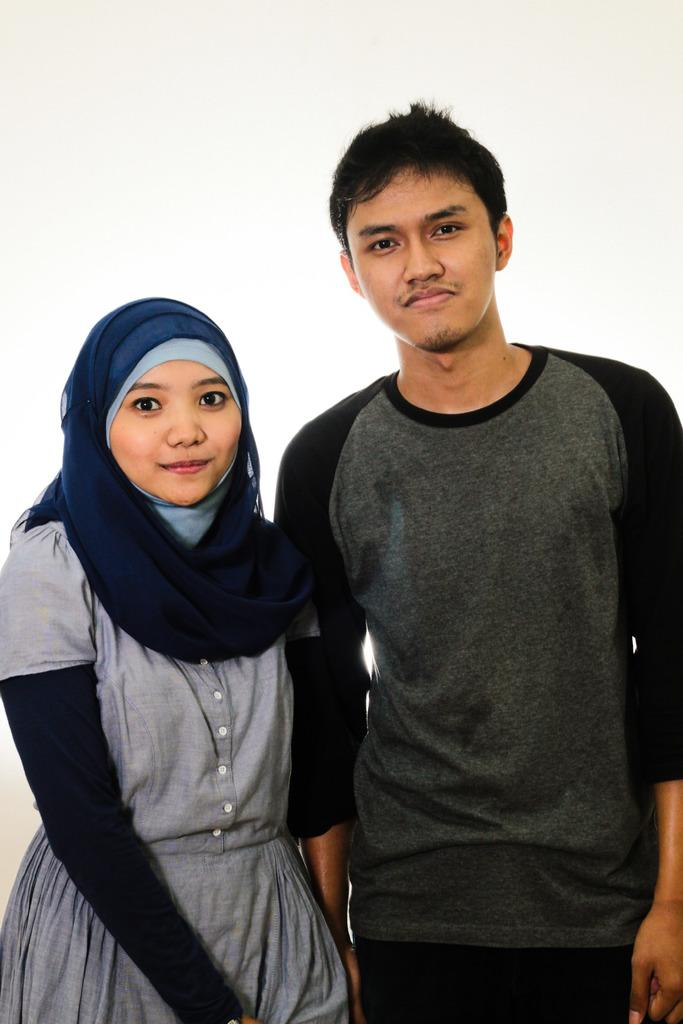How many people are in the image? There are two persons in the image. What are the persons doing in the image? The persons are standing in the image. What expression do the persons have in the image? The persons are smiling in the image. What type of loss can be seen in the image? There is no loss depicted in the image; it features two persons standing and smiling. How many dimes are visible in the image? There are no dimes present in the image. 